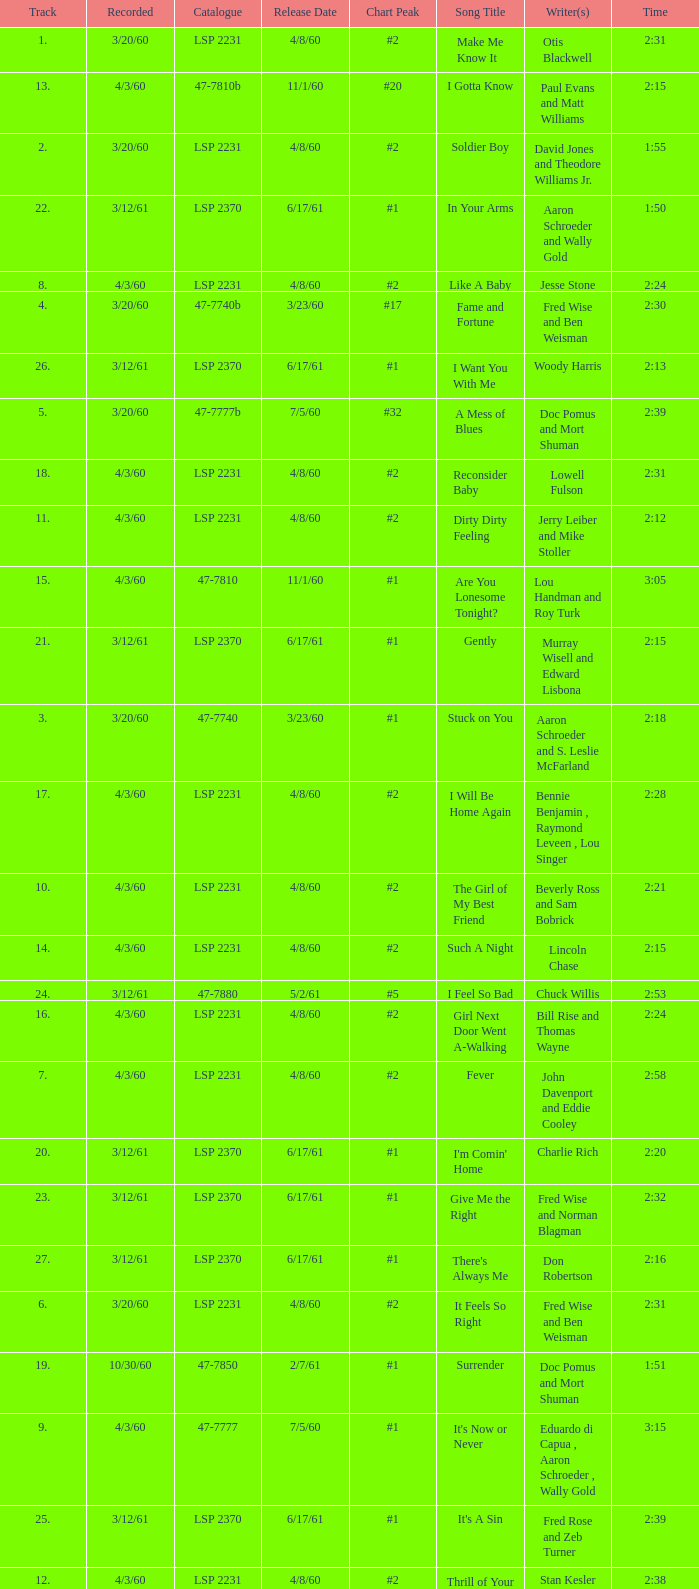On songs with track numbers smaller than number 17 and catalogues of LSP 2231, who are the writer(s)? Otis Blackwell, David Jones and Theodore Williams Jr., Fred Wise and Ben Weisman, John Davenport and Eddie Cooley, Jesse Stone, Beverly Ross and Sam Bobrick, Jerry Leiber and Mike Stoller, Stan Kesler, Lincoln Chase, Bill Rise and Thomas Wayne. Would you mind parsing the complete table? {'header': ['Track', 'Recorded', 'Catalogue', 'Release Date', 'Chart Peak', 'Song Title', 'Writer(s)', 'Time'], 'rows': [['1.', '3/20/60', 'LSP 2231', '4/8/60', '#2', 'Make Me Know It', 'Otis Blackwell', '2:31'], ['13.', '4/3/60', '47-7810b', '11/1/60', '#20', 'I Gotta Know', 'Paul Evans and Matt Williams', '2:15'], ['2.', '3/20/60', 'LSP 2231', '4/8/60', '#2', 'Soldier Boy', 'David Jones and Theodore Williams Jr.', '1:55'], ['22.', '3/12/61', 'LSP 2370', '6/17/61', '#1', 'In Your Arms', 'Aaron Schroeder and Wally Gold', '1:50'], ['8.', '4/3/60', 'LSP 2231', '4/8/60', '#2', 'Like A Baby', 'Jesse Stone', '2:24'], ['4.', '3/20/60', '47-7740b', '3/23/60', '#17', 'Fame and Fortune', 'Fred Wise and Ben Weisman', '2:30'], ['26.', '3/12/61', 'LSP 2370', '6/17/61', '#1', 'I Want You With Me', 'Woody Harris', '2:13'], ['5.', '3/20/60', '47-7777b', '7/5/60', '#32', 'A Mess of Blues', 'Doc Pomus and Mort Shuman', '2:39'], ['18.', '4/3/60', 'LSP 2231', '4/8/60', '#2', 'Reconsider Baby', 'Lowell Fulson', '2:31'], ['11.', '4/3/60', 'LSP 2231', '4/8/60', '#2', 'Dirty Dirty Feeling', 'Jerry Leiber and Mike Stoller', '2:12'], ['15.', '4/3/60', '47-7810', '11/1/60', '#1', 'Are You Lonesome Tonight?', 'Lou Handman and Roy Turk', '3:05'], ['21.', '3/12/61', 'LSP 2370', '6/17/61', '#1', 'Gently', 'Murray Wisell and Edward Lisbona', '2:15'], ['3.', '3/20/60', '47-7740', '3/23/60', '#1', 'Stuck on You', 'Aaron Schroeder and S. Leslie McFarland', '2:18'], ['17.', '4/3/60', 'LSP 2231', '4/8/60', '#2', 'I Will Be Home Again', 'Bennie Benjamin , Raymond Leveen , Lou Singer', '2:28'], ['10.', '4/3/60', 'LSP 2231', '4/8/60', '#2', 'The Girl of My Best Friend', 'Beverly Ross and Sam Bobrick', '2:21'], ['14.', '4/3/60', 'LSP 2231', '4/8/60', '#2', 'Such A Night', 'Lincoln Chase', '2:15'], ['24.', '3/12/61', '47-7880', '5/2/61', '#5', 'I Feel So Bad', 'Chuck Willis', '2:53'], ['16.', '4/3/60', 'LSP 2231', '4/8/60', '#2', 'Girl Next Door Went A-Walking', 'Bill Rise and Thomas Wayne', '2:24'], ['7.', '4/3/60', 'LSP 2231', '4/8/60', '#2', 'Fever', 'John Davenport and Eddie Cooley', '2:58'], ['20.', '3/12/61', 'LSP 2370', '6/17/61', '#1', "I'm Comin' Home", 'Charlie Rich', '2:20'], ['23.', '3/12/61', 'LSP 2370', '6/17/61', '#1', 'Give Me the Right', 'Fred Wise and Norman Blagman', '2:32'], ['27.', '3/12/61', 'LSP 2370', '6/17/61', '#1', "There's Always Me", 'Don Robertson', '2:16'], ['6.', '3/20/60', 'LSP 2231', '4/8/60', '#2', 'It Feels So Right', 'Fred Wise and Ben Weisman', '2:31'], ['19.', '10/30/60', '47-7850', '2/7/61', '#1', 'Surrender', 'Doc Pomus and Mort Shuman', '1:51'], ['9.', '4/3/60', '47-7777', '7/5/60', '#1', "It's Now or Never", 'Eduardo di Capua , Aaron Schroeder , Wally Gold', '3:15'], ['25.', '3/12/61', 'LSP 2370', '6/17/61', '#1', "It's A Sin", 'Fred Rose and Zeb Turner', '2:39'], ['12.', '4/3/60', 'LSP 2231', '4/8/60', '#2', 'Thrill of Your Love', 'Stan Kesler', '2:38']]} 